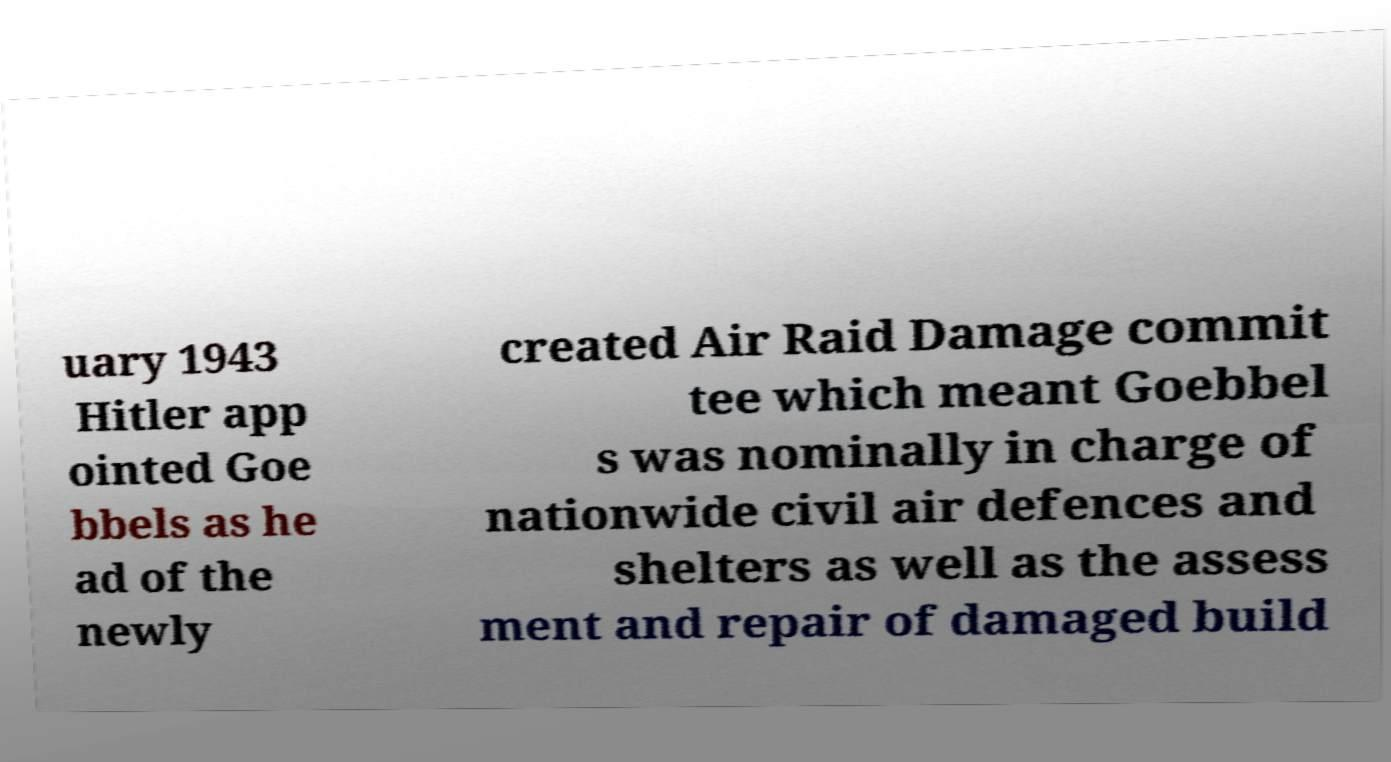I need the written content from this picture converted into text. Can you do that? uary 1943 Hitler app ointed Goe bbels as he ad of the newly created Air Raid Damage commit tee which meant Goebbel s was nominally in charge of nationwide civil air defences and shelters as well as the assess ment and repair of damaged build 